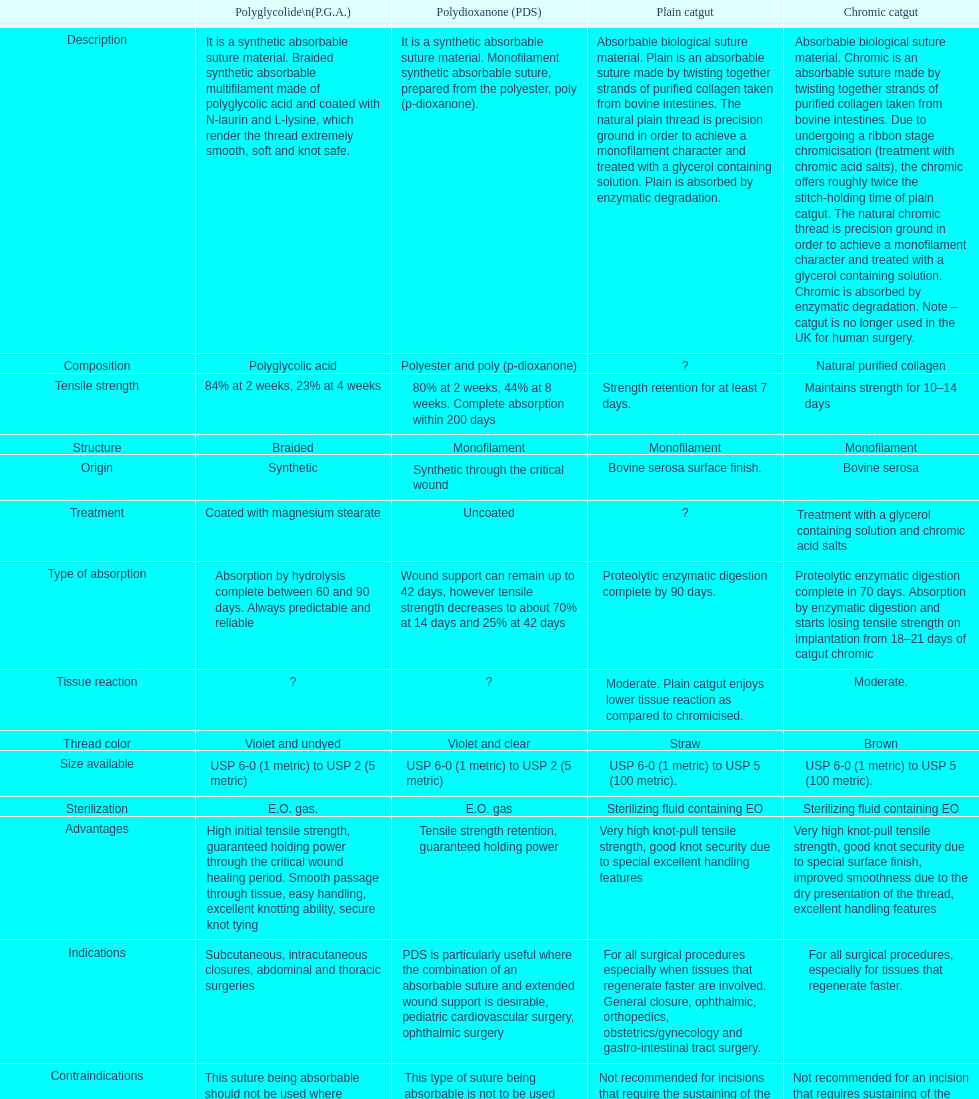What is the arrangement other than monofilament? Braided. 